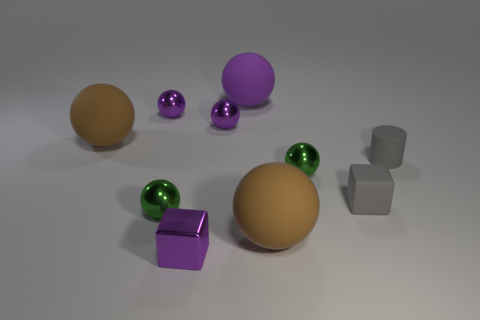Subtract all purple spheres. How many were subtracted if there are1purple spheres left? 2 Subtract all green cylinders. How many purple spheres are left? 3 Subtract all brown spheres. How many spheres are left? 5 Subtract all purple shiny balls. How many balls are left? 5 Subtract all cyan spheres. Subtract all blue cylinders. How many spheres are left? 7 Subtract all blocks. How many objects are left? 8 Subtract 0 yellow blocks. How many objects are left? 10 Subtract all green objects. Subtract all big brown rubber spheres. How many objects are left? 6 Add 6 gray cylinders. How many gray cylinders are left? 7 Add 4 small red rubber balls. How many small red rubber balls exist? 4 